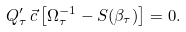Convert formula to latex. <formula><loc_0><loc_0><loc_500><loc_500>Q _ { \tau } ^ { \prime } \, \vec { c } \left [ \Omega _ { \tau } ^ { - 1 } - S ( \beta _ { \tau } ) \right ] = 0 .</formula> 